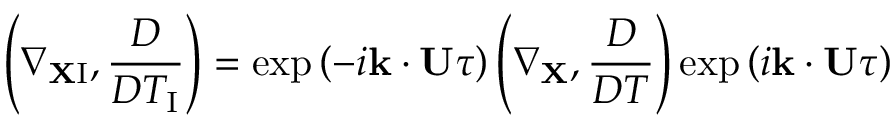<formula> <loc_0><loc_0><loc_500><loc_500>\left ( { \nabla _ { { X } { I } } , \frac { D } { D T _ { I } } } \right ) = \exp \left ( { - i { k } \cdot { U } \tau } \right ) \left ( { \nabla _ { X } , \frac { D } { D T } } \right ) \exp \left ( { i { k } \cdot { U } \tau } \right )</formula> 